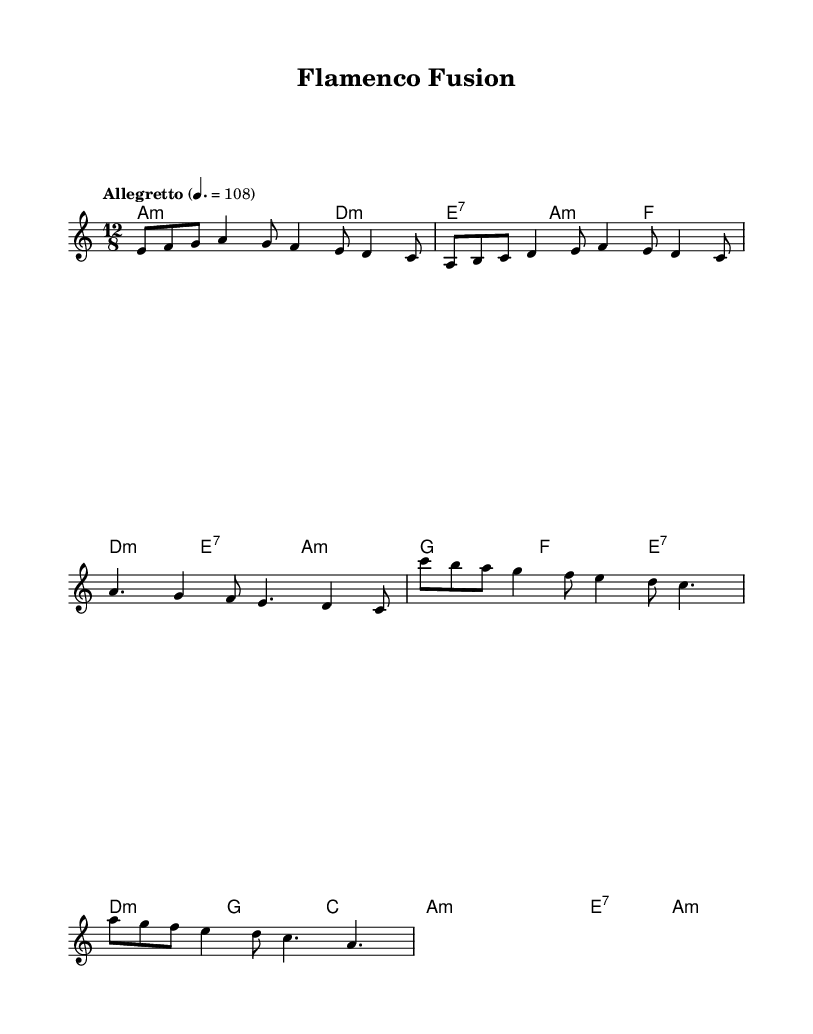What is the key signature of this music? The key signature is A minor, which has no sharps or flats.
Answer: A minor What is the time signature? The time signature is indicated at the beginning of the score and is 12/8, which means there are 12 eighth notes per measure.
Answer: 12/8 What is the tempo marking? The tempo marking indicates the speed of the piece; here it is marked as "Allegretto" at a metronome marking of 108 beats per minute.
Answer: Allegretto What chords are used in the chorus section? The chorus consists of chords A, G, F, E, D, and C, played at various durations as indicated in the chord names.
Answer: A, G, F, E, D, C How many measures are in the verse section? The verse section spans 4 measures, as can be counted by the number of vocal or instrumental phrases presented.
Answer: 4 What is the main style depicted in this score? The score is a fusion that adapts traditional Spanish flamenco guitar techniques for modern audiences, incorporating the essence of flamenco music.
Answer: Flamenco fusion 